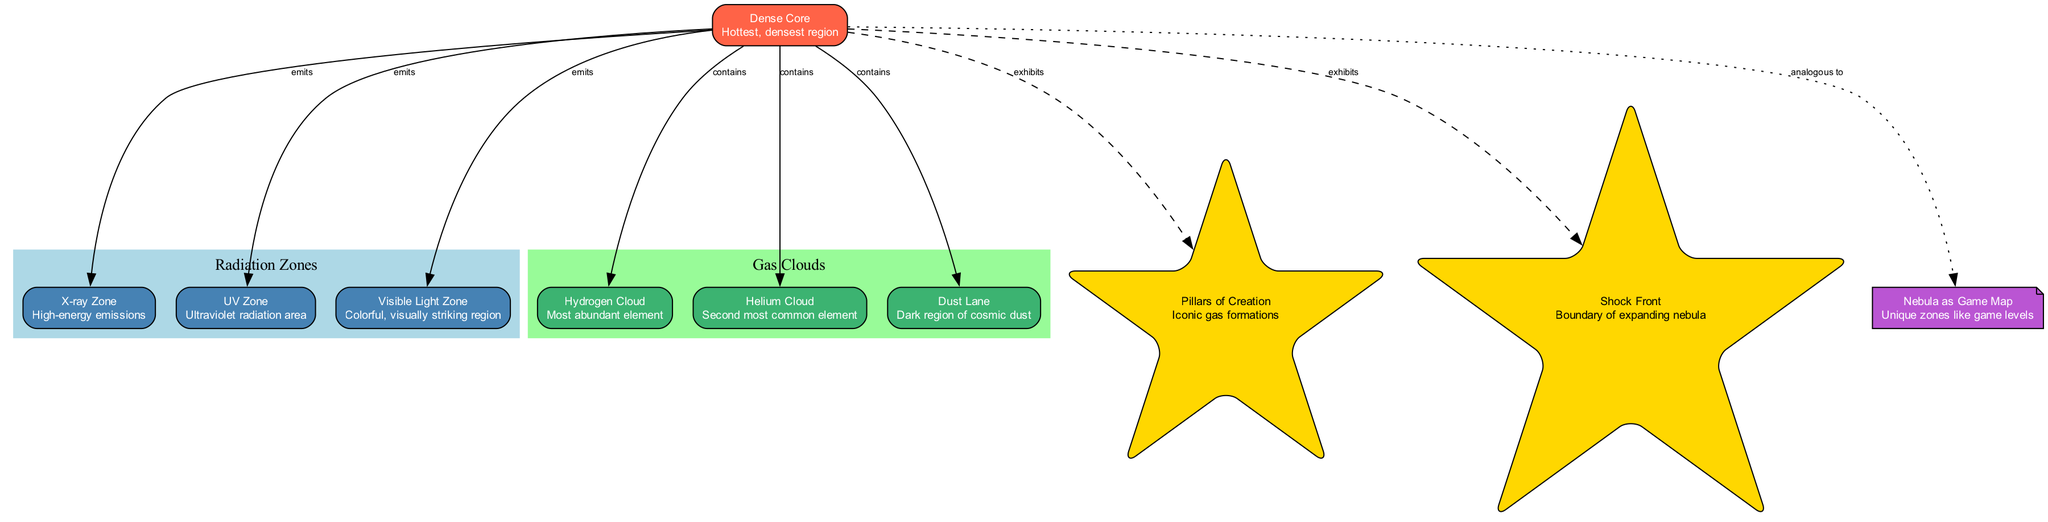What is the name of the central core in the nebula? The diagram indicates that the central core is referred to as the "Dense Core". This is directly stated in the node labeled "core".
Answer: Dense Core How many radiation zones are present in the diagram? The diagram contains three nodes that represent radiation zones, namely the X-ray Zone, UV Zone, and Visible Light Zone. Counting these nodes gives a total of three.
Answer: 3 What is the description of the UV Zone? The UV Zone node specifically describes it as an area with "Ultraviolet radiation". This description can be found in the corresponding radiation zone node.
Answer: Ultraviolet radiation area Which notable feature is represented by a star shape? Notable features in the diagram are indicated with star shapes; one such feature is labeled as "Pillars of Creation". This can be observed as a star-shaped node connected to the central core.
Answer: Pillars of Creation How do gas clouds differ from radiation zones in the diagram? Gas clouds and radiation zones are grouped under different subgraphs; gas clouds include clouds like Hydrogen and Helium while radiation zones focus on emissions like X-ray and UV. This distinction is visually represented in the diagram's structure.
Answer: Different subgraphs What type of connection is indicated between the central core and the gaming analogy? The connection between the central core and the gaming analogy node is represented by a dotted line, indicating an analogous relationship. This can be observed in the edge connecting these two nodes.
Answer: Analogous to How many gas clouds are depicted in the diagram? Upon reviewing the gas clouds subgraph, there are three nodes labeled as Hydrogen Cloud, Helium Cloud, and Dust Lane. This indicates that the diagram depicts three gas clouds.
Answer: 3 What is the boundary of the expanding nebula called in the diagram? The diagram features a notable area labeled "Shock Front", which is identified as the boundary of the expanding nebula. This information is captured in the features section.
Answer: Shock Front Which radiation zone emits high-energy emissions? The diagram identifies the "X-ray Zone" as the zone associated with high-energy emissions, detailed in its respective node.
Answer: X-ray Zone 